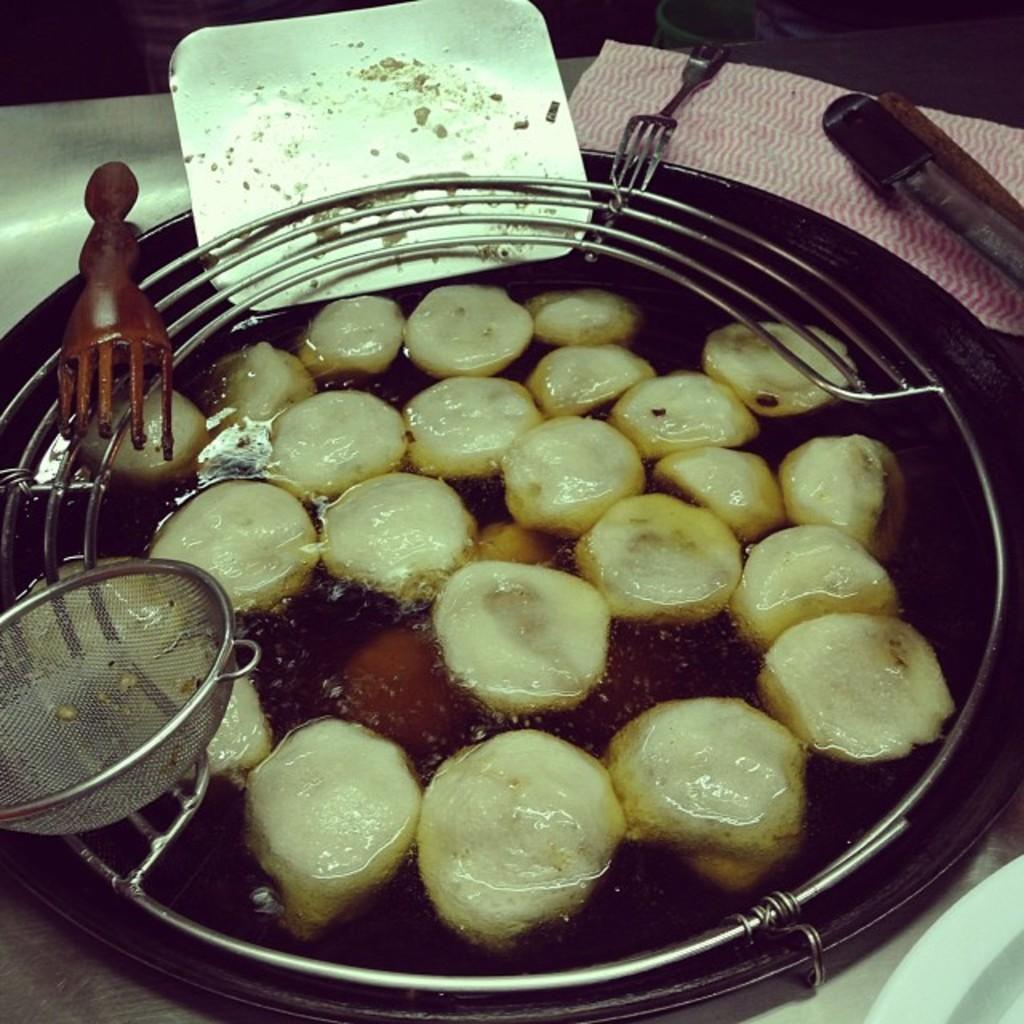Describe this image in one or two sentences. In this picture there is food in the bowl. There is a bowl, fork and there is a spoon and there are objects and their might be tissue on the table. 